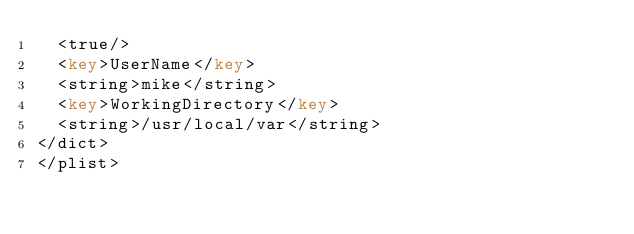<code> <loc_0><loc_0><loc_500><loc_500><_XML_>  <true/>
  <key>UserName</key>
  <string>mike</string>
  <key>WorkingDirectory</key>
  <string>/usr/local/var</string>
</dict>
</plist>
</code> 